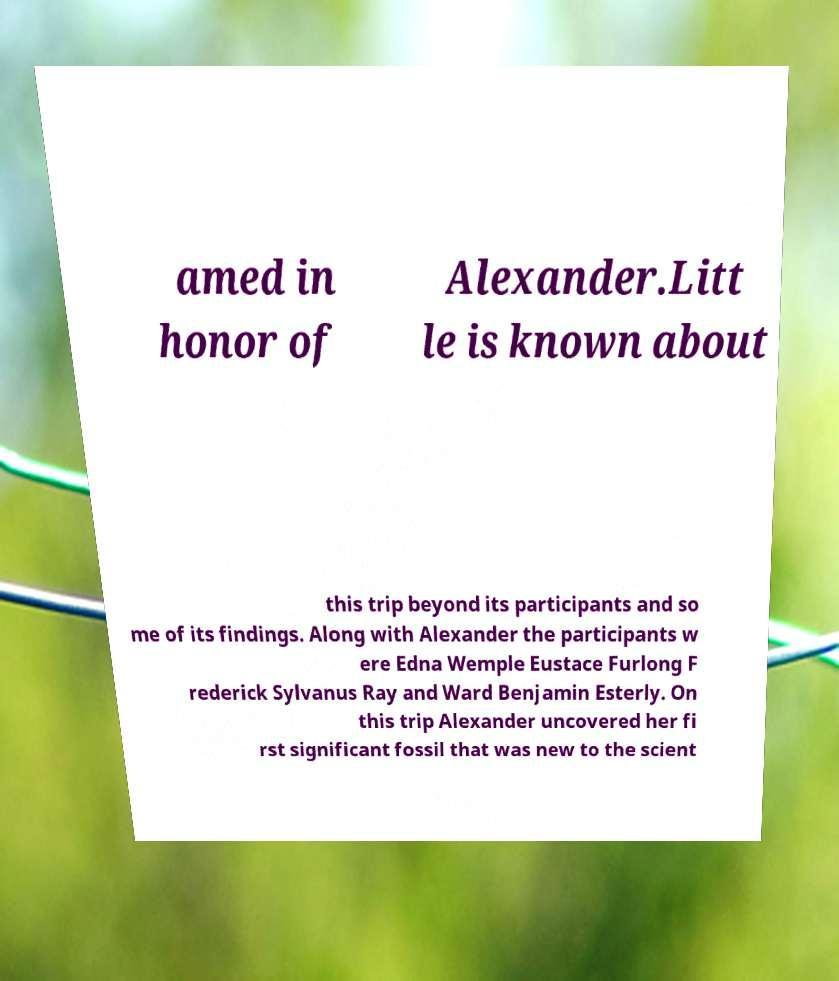There's text embedded in this image that I need extracted. Can you transcribe it verbatim? amed in honor of Alexander.Litt le is known about this trip beyond its participants and so me of its findings. Along with Alexander the participants w ere Edna Wemple Eustace Furlong F rederick Sylvanus Ray and Ward Benjamin Esterly. On this trip Alexander uncovered her fi rst significant fossil that was new to the scient 